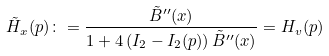<formula> <loc_0><loc_0><loc_500><loc_500>\tilde { H } _ { x } ( p ) \colon = \frac { \tilde { B } ^ { \prime \prime } ( x ) } { 1 + 4 \left ( I _ { 2 } - I _ { 2 } ( p ) \right ) \tilde { B } ^ { \prime \prime } ( x ) } = H _ { v } ( p )</formula> 